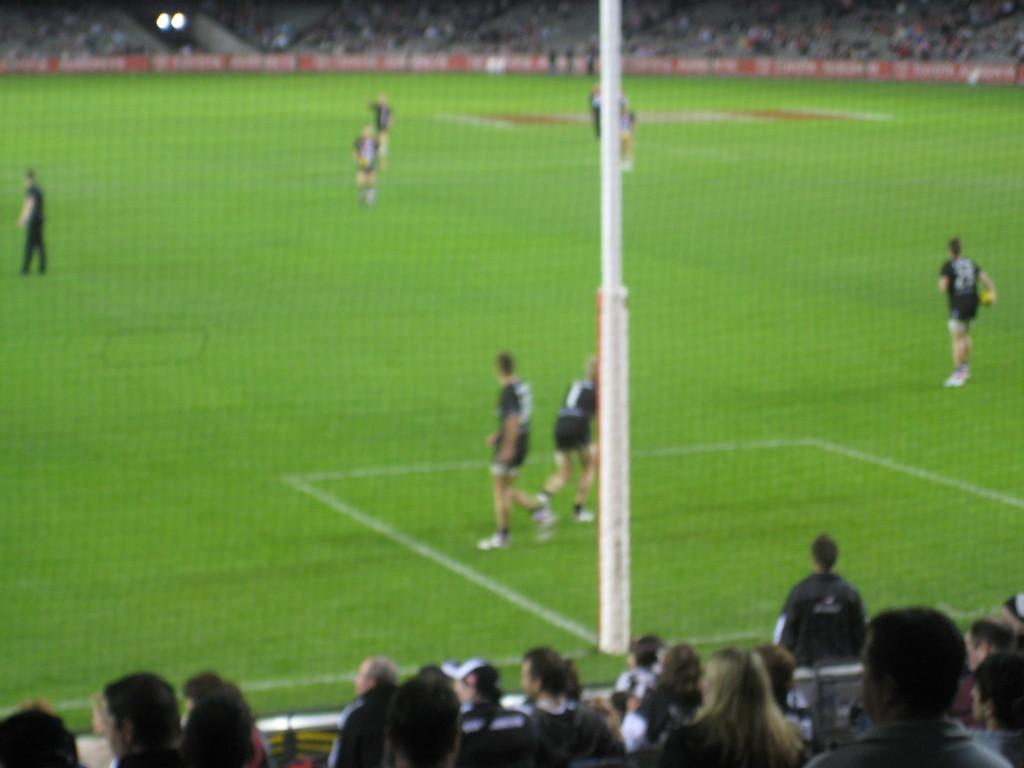What is the primary setting of the image? There is a ground in the image. What activity is taking place on the ground? There are players playing on the ground. Are there any observers present in the image? Yes, there are spectators around the ground. What type of sweater is the spectator wearing in the image? There is no information about a sweater or any specific clothing worn by the spectators in the image. 